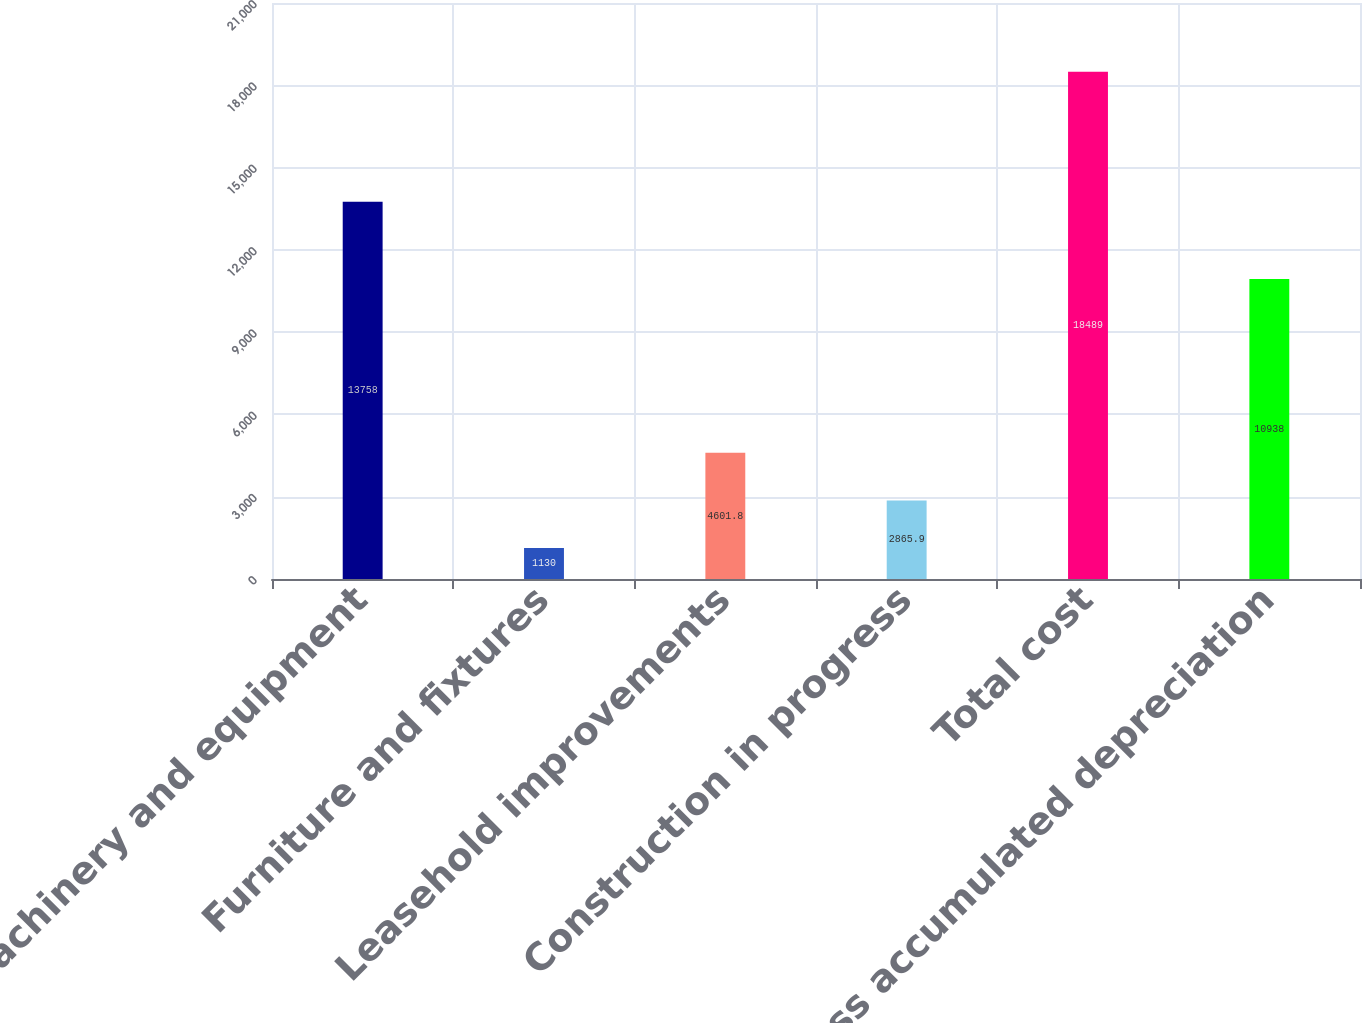Convert chart. <chart><loc_0><loc_0><loc_500><loc_500><bar_chart><fcel>Machinery and equipment<fcel>Furniture and fixtures<fcel>Leasehold improvements<fcel>Construction in progress<fcel>Total cost<fcel>Less accumulated depreciation<nl><fcel>13758<fcel>1130<fcel>4601.8<fcel>2865.9<fcel>18489<fcel>10938<nl></chart> 